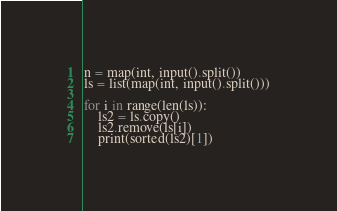<code> <loc_0><loc_0><loc_500><loc_500><_Python_>n = map(int, input().split())
ls = list(map(int, input().split()))

for i in range(len(ls)):
    ls2 = ls.copy()
    ls2.remove(ls[i])
    print(sorted(ls2)[1])
</code> 